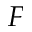Convert formula to latex. <formula><loc_0><loc_0><loc_500><loc_500>_ { F }</formula> 